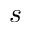<formula> <loc_0><loc_0><loc_500><loc_500>s</formula> 